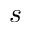<formula> <loc_0><loc_0><loc_500><loc_500>s</formula> 